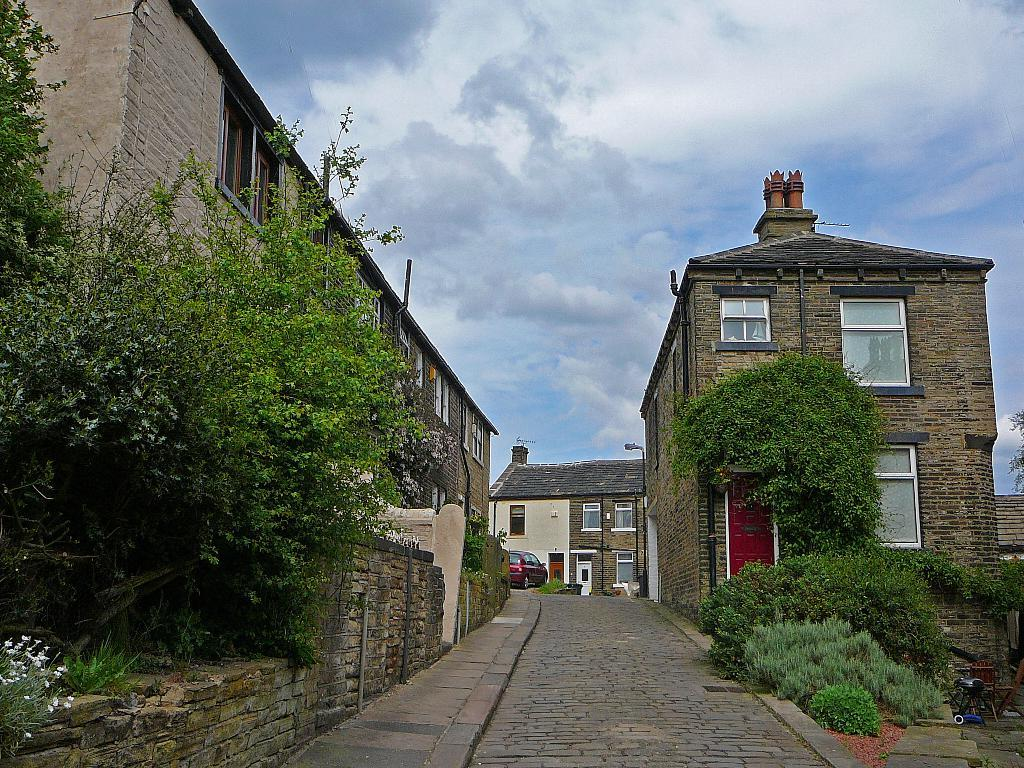Where was the image taken? The image was clicked outside. What can be seen in the middle of the image? There are buildings, trees, and bushes in the middle of the image. What is visible at the top of the image? The sky is visible at the top of the image. What is located at the bottom of the image? There is a car at the bottom of the image. Can you see a fireman putting out a fire in the image? There is no fire or fireman present in the image. What is the example of a sneeze in the image? There is no example of a sneeze in the image. 